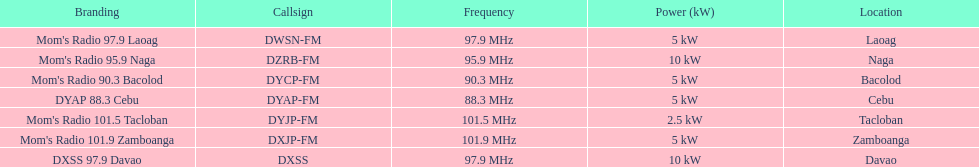How do the kilowatt outputs of naga and bacolod radio stations differ? 5 kW. 